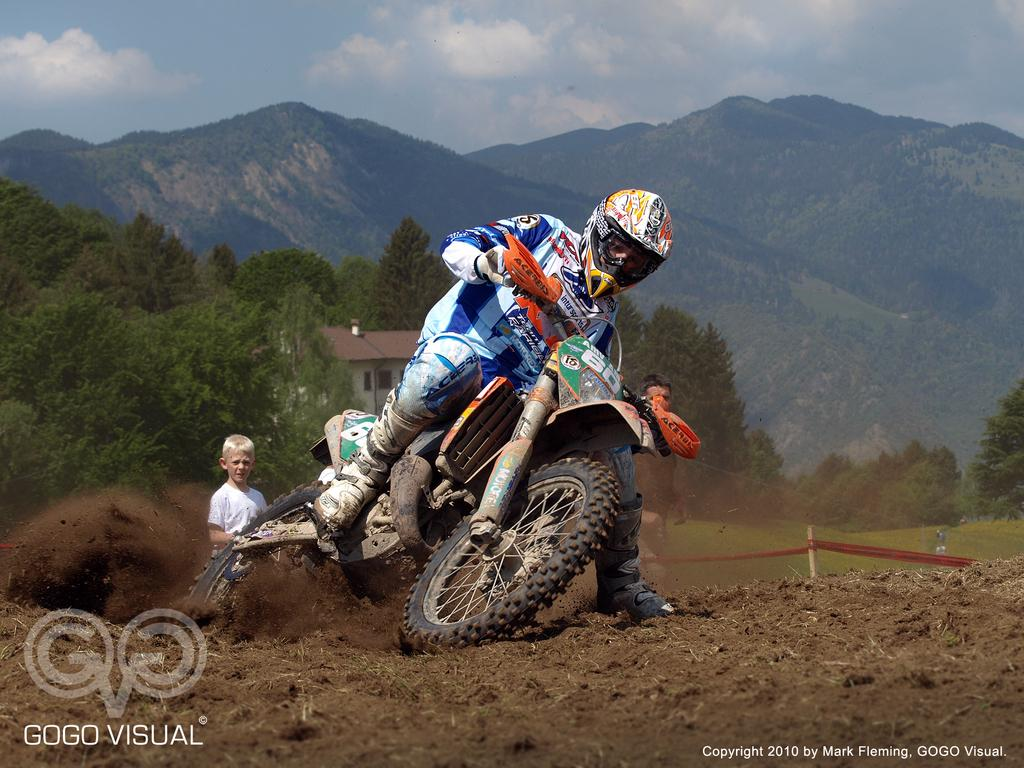How many people are in the image? There are three people in the image. What are the people doing in the image? One person is riding a bike on the ground. What can be seen in the background of the image? There are trees, mountains, a house, and the sky visible in the background of the image. What type of pies are being served at the picnic in the image? There is no picnic or pies present in the image. Can you tell me how many people are smiling in the image? The provided facts do not mention anyone smiling in the image. 